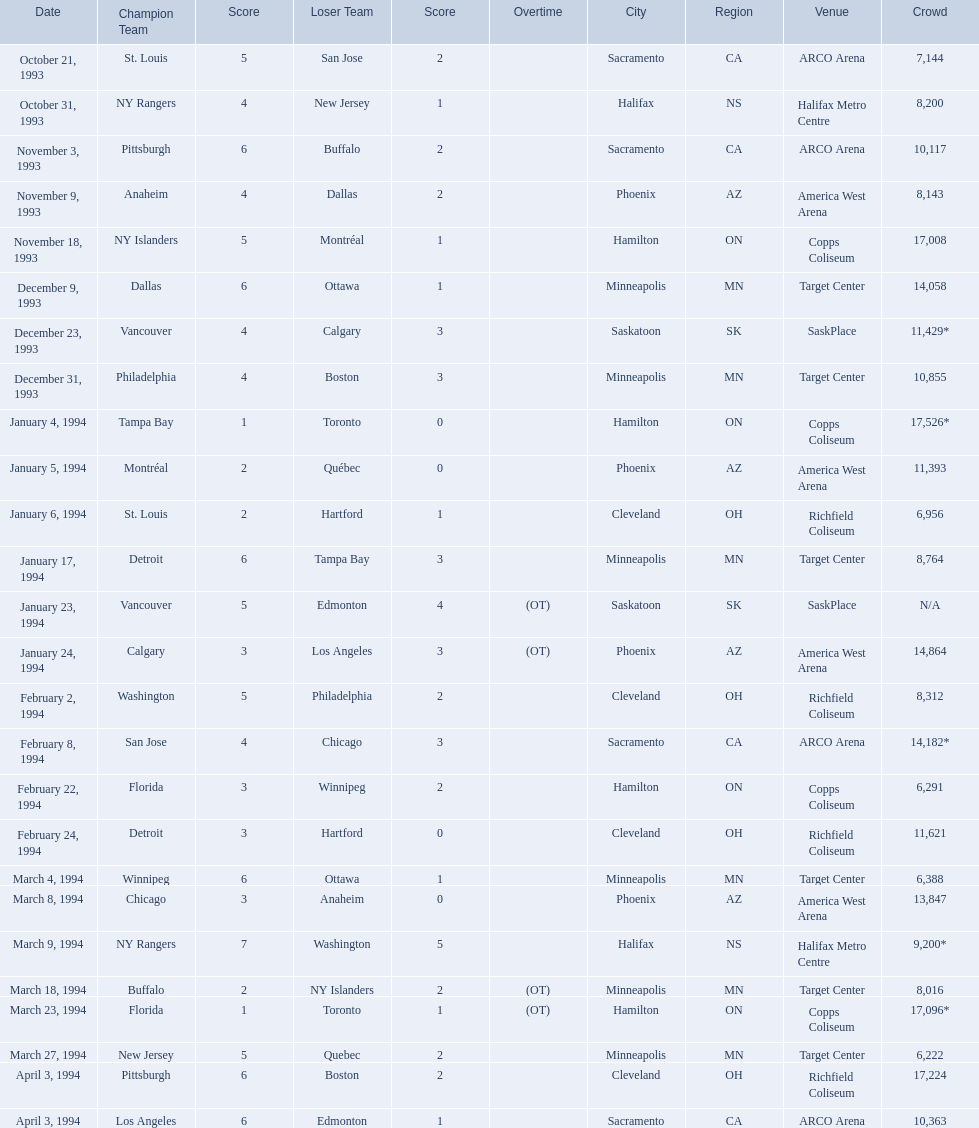What was the attendance on january 24, 1994? 14,864. What was the attendance on december 23, 1993? 11,429*. Between january 24, 1994 and december 23, 1993, which had the higher attendance? January 4, 1994. 